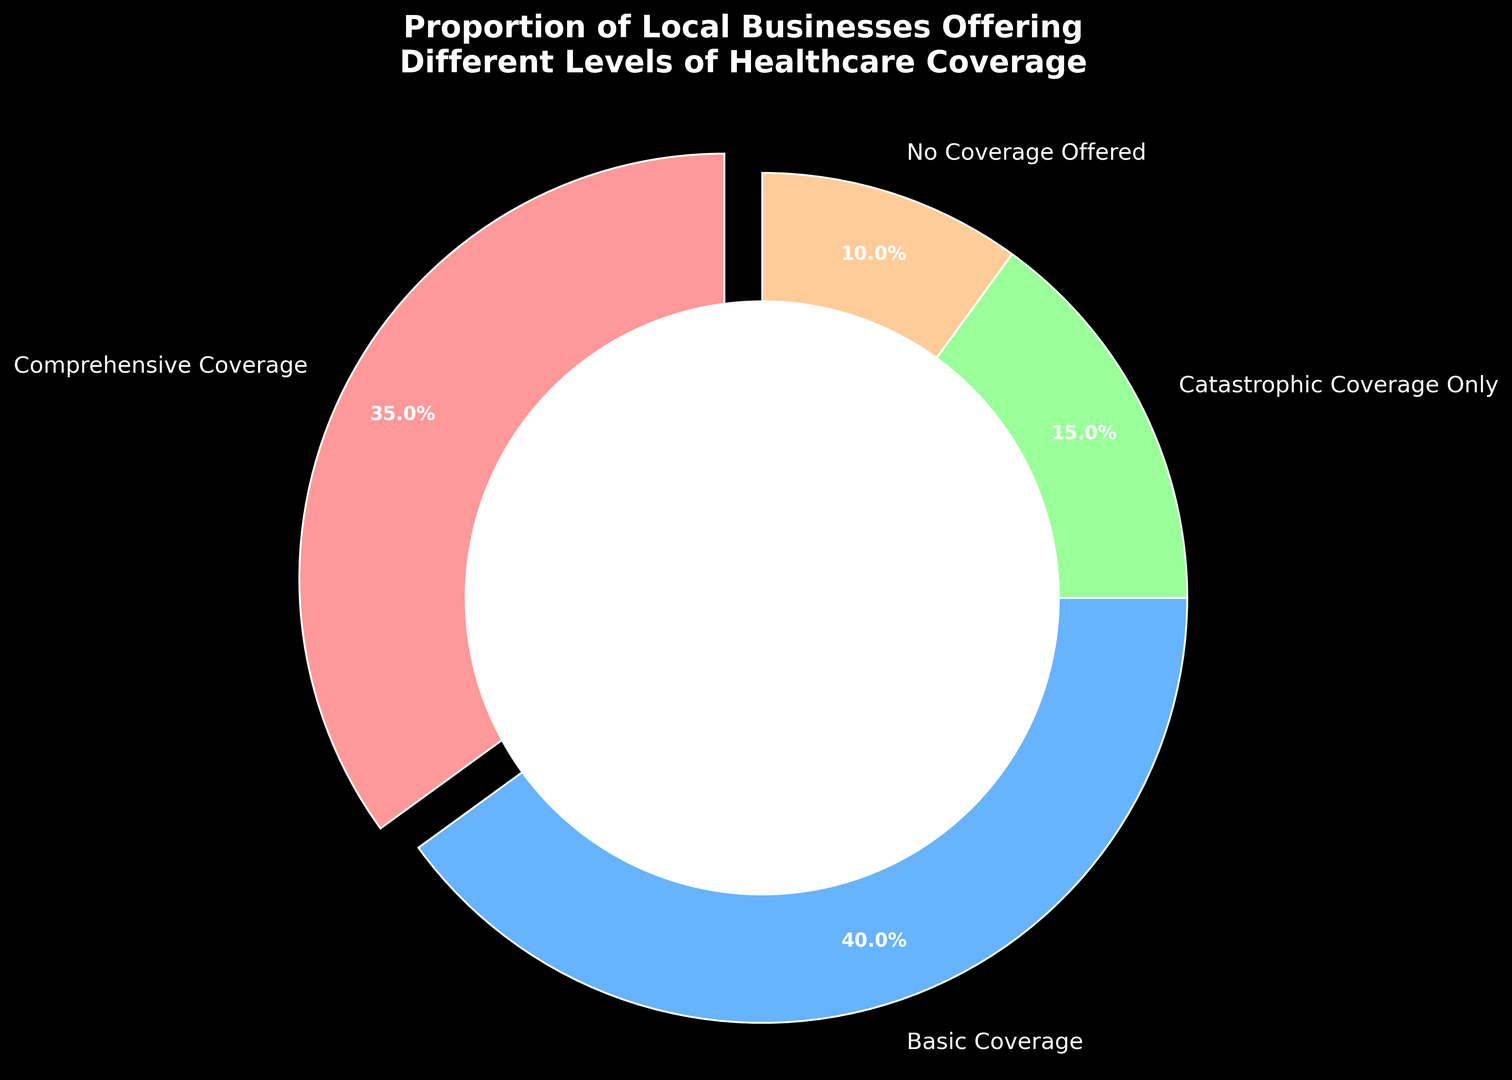What proportion of local businesses provides no healthcare coverage? The slice labeled "No Coverage Offered" represents the businesses offering no healthcare coverage. The chart shows this as 10%.
Answer: 10% Which level of healthcare coverage is offered by the most local businesses? By looking at the sizes of the slices, "Basic Coverage" is the largest slice, indicating it is offered by the most businesses.
Answer: Basic Coverage What's the total percentage of local businesses offering some form of healthcare coverage? Sum the percentages of businesses offering Comprehensive Coverage, Basic Coverage, and Catastrophic Coverage Only. This is 35% + 40% + 15% = 90%.
Answer: 90% How does the proportion of businesses offering Basic Coverage compare to those offering Comprehensive Coverage? The "Basic Coverage" slice represents 40%, while "Comprehensive Coverage" is 35%. 40% is greater than 35%.
Answer: Basic Coverage is 5% higher than Comprehensive Coverage Does the percentage of businesses offering Catastrophic Coverage Only exceed 20%? The "Catastrophic Coverage Only" slice shows 15%. This is less than 20%.
Answer: No What proportion of businesses offer more than just Catastrophic Coverage (i.e., Basic or Comprehensive Coverage)? Sum the percentages of "Basic Coverage" and "Comprehensive Coverage". This is 40% + 35% = 75%.
Answer: 75% Which levels of healthcare coverage are offered by less than 20% of businesses? Identify slices with percentages less than 20%. "Catastrophic Coverage Only" (15%) and "No Coverage Offered" (10%) fit this criterion.
Answer: Catastrophic Coverage Only, No Coverage Offered How does the visual representation of the "Basic Coverage" slice compare to the "Comprehensive Coverage" slice? The "Basic Coverage" slice is slightly larger than the "Comprehensive Coverage" slice, indicating Basic Coverage is offered by a higher percentage of businesses.
Answer: "Basic Coverage" slice is larger If 200 local businesses exist, how many are offering no healthcare coverage? Multiply the total number of businesses (200) by the percentage offering no healthcare coverage (10%). 200 * 0.10 = 20 businesses.
Answer: 20 businesses 